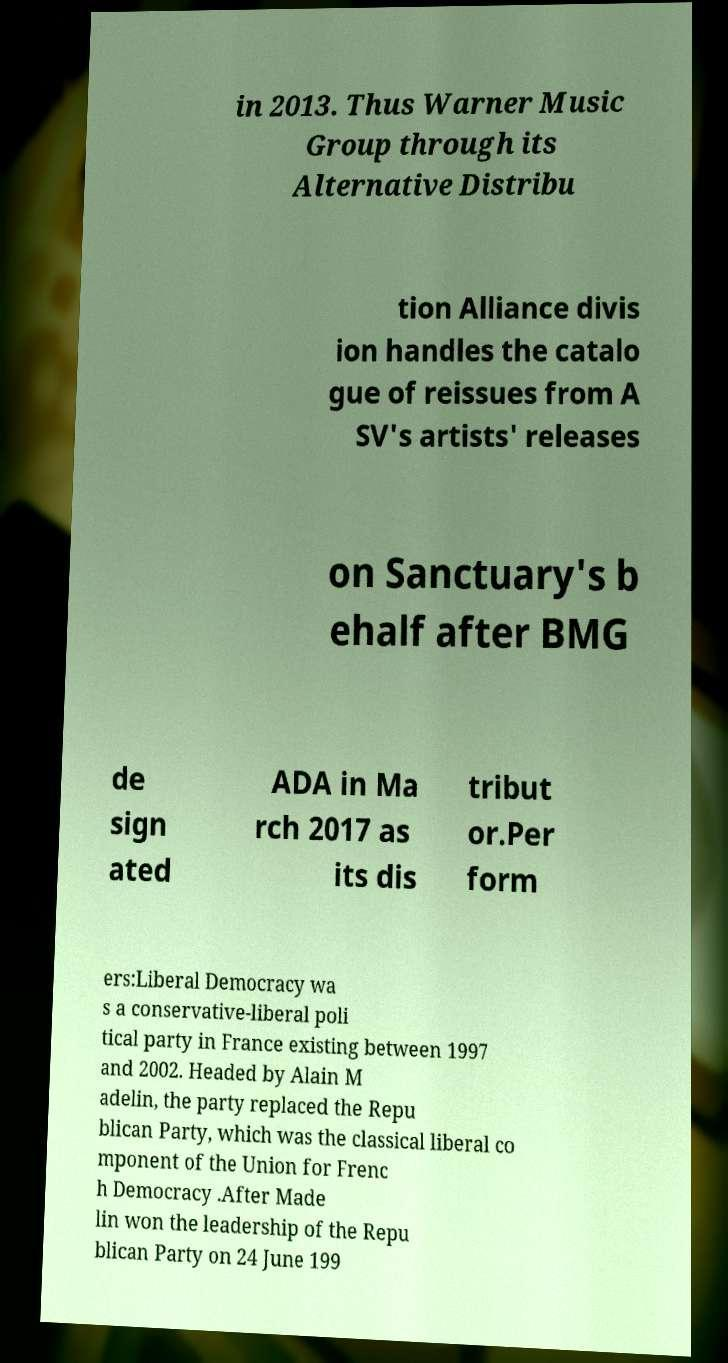I need the written content from this picture converted into text. Can you do that? in 2013. Thus Warner Music Group through its Alternative Distribu tion Alliance divis ion handles the catalo gue of reissues from A SV's artists' releases on Sanctuary's b ehalf after BMG de sign ated ADA in Ma rch 2017 as its dis tribut or.Per form ers:Liberal Democracy wa s a conservative-liberal poli tical party in France existing between 1997 and 2002. Headed by Alain M adelin, the party replaced the Repu blican Party, which was the classical liberal co mponent of the Union for Frenc h Democracy .After Made lin won the leadership of the Repu blican Party on 24 June 199 